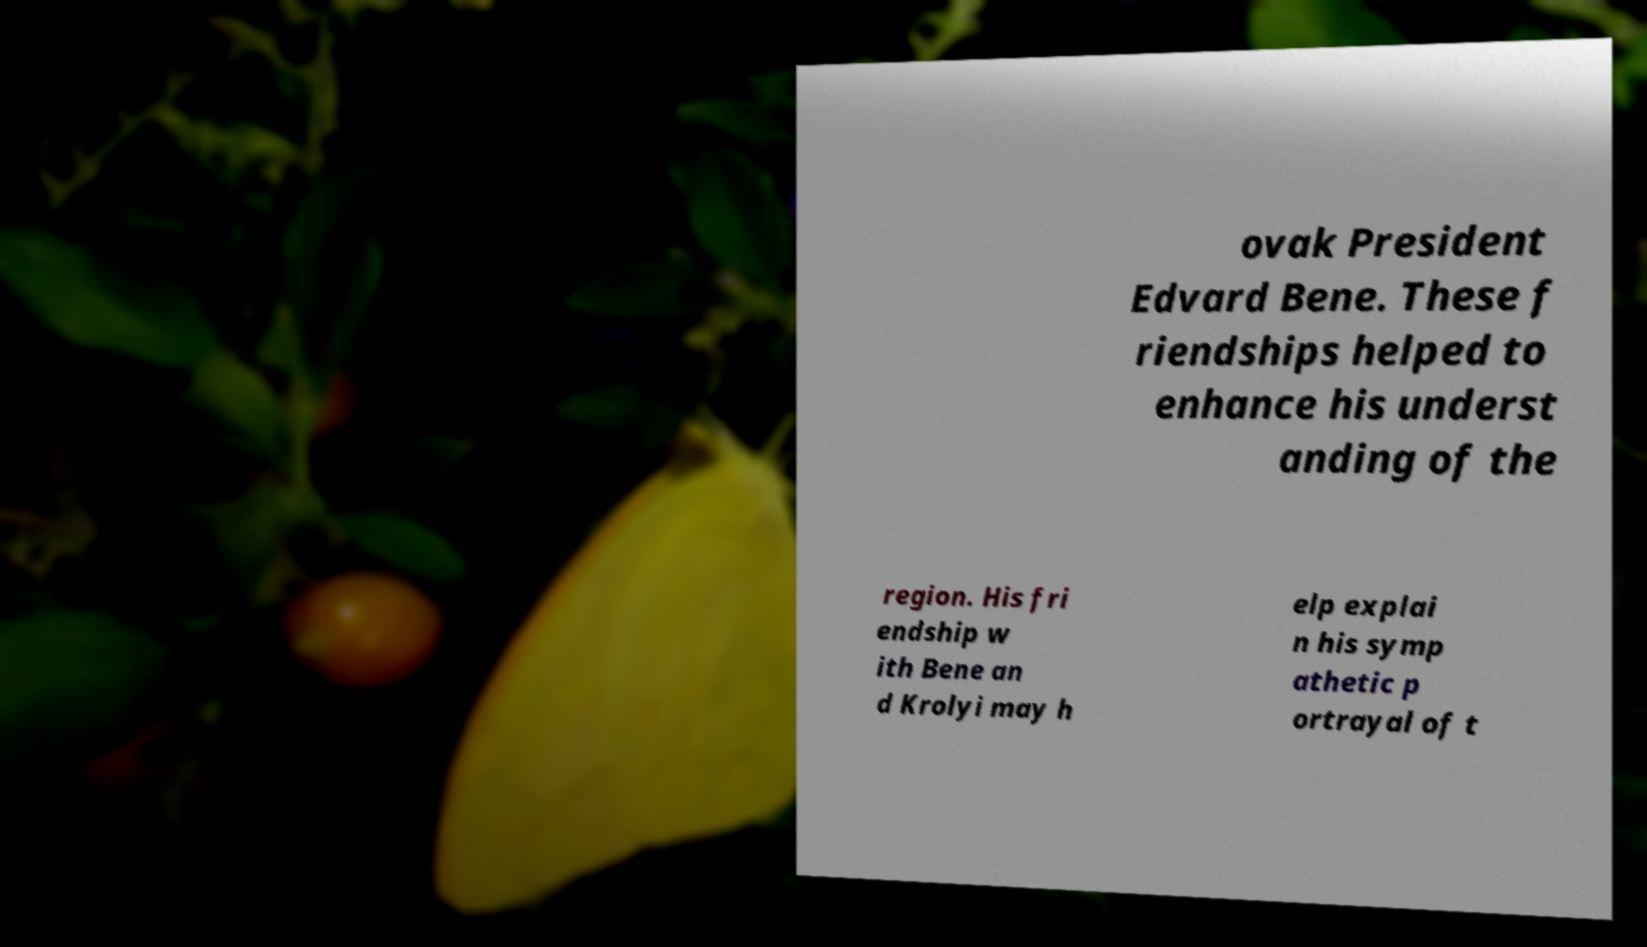Could you extract and type out the text from this image? ovak President Edvard Bene. These f riendships helped to enhance his underst anding of the region. His fri endship w ith Bene an d Krolyi may h elp explai n his symp athetic p ortrayal of t 